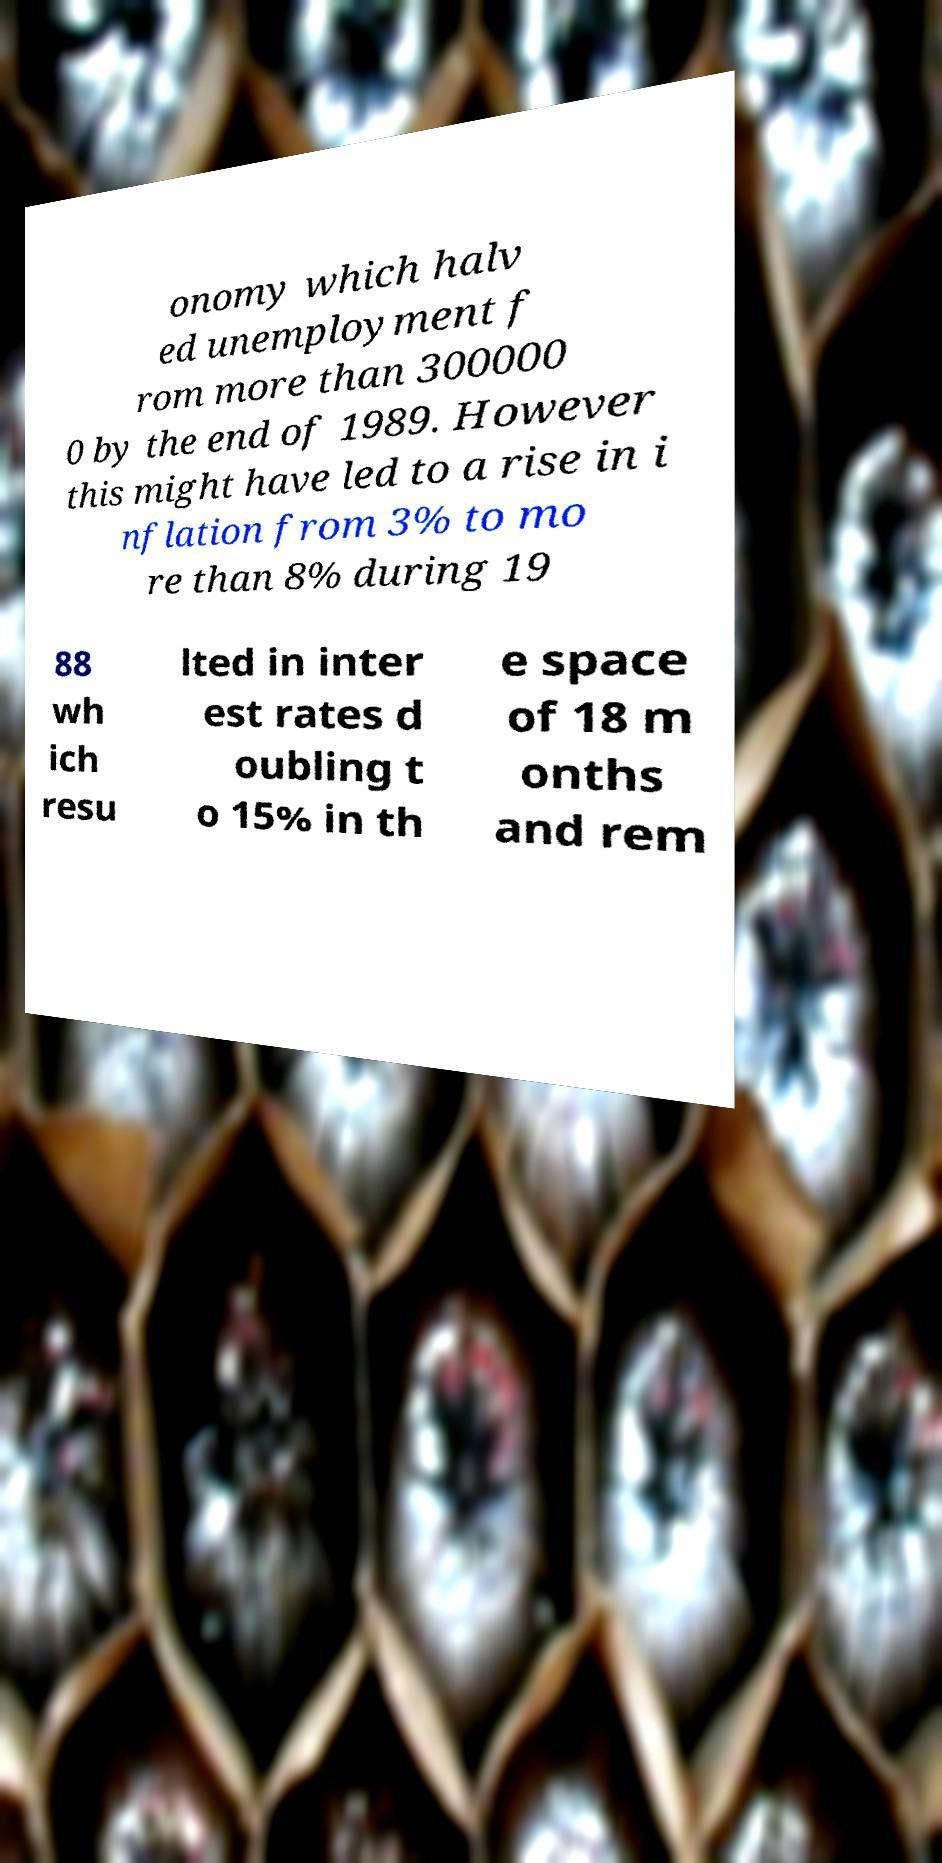Can you accurately transcribe the text from the provided image for me? onomy which halv ed unemployment f rom more than 300000 0 by the end of 1989. However this might have led to a rise in i nflation from 3% to mo re than 8% during 19 88 wh ich resu lted in inter est rates d oubling t o 15% in th e space of 18 m onths and rem 